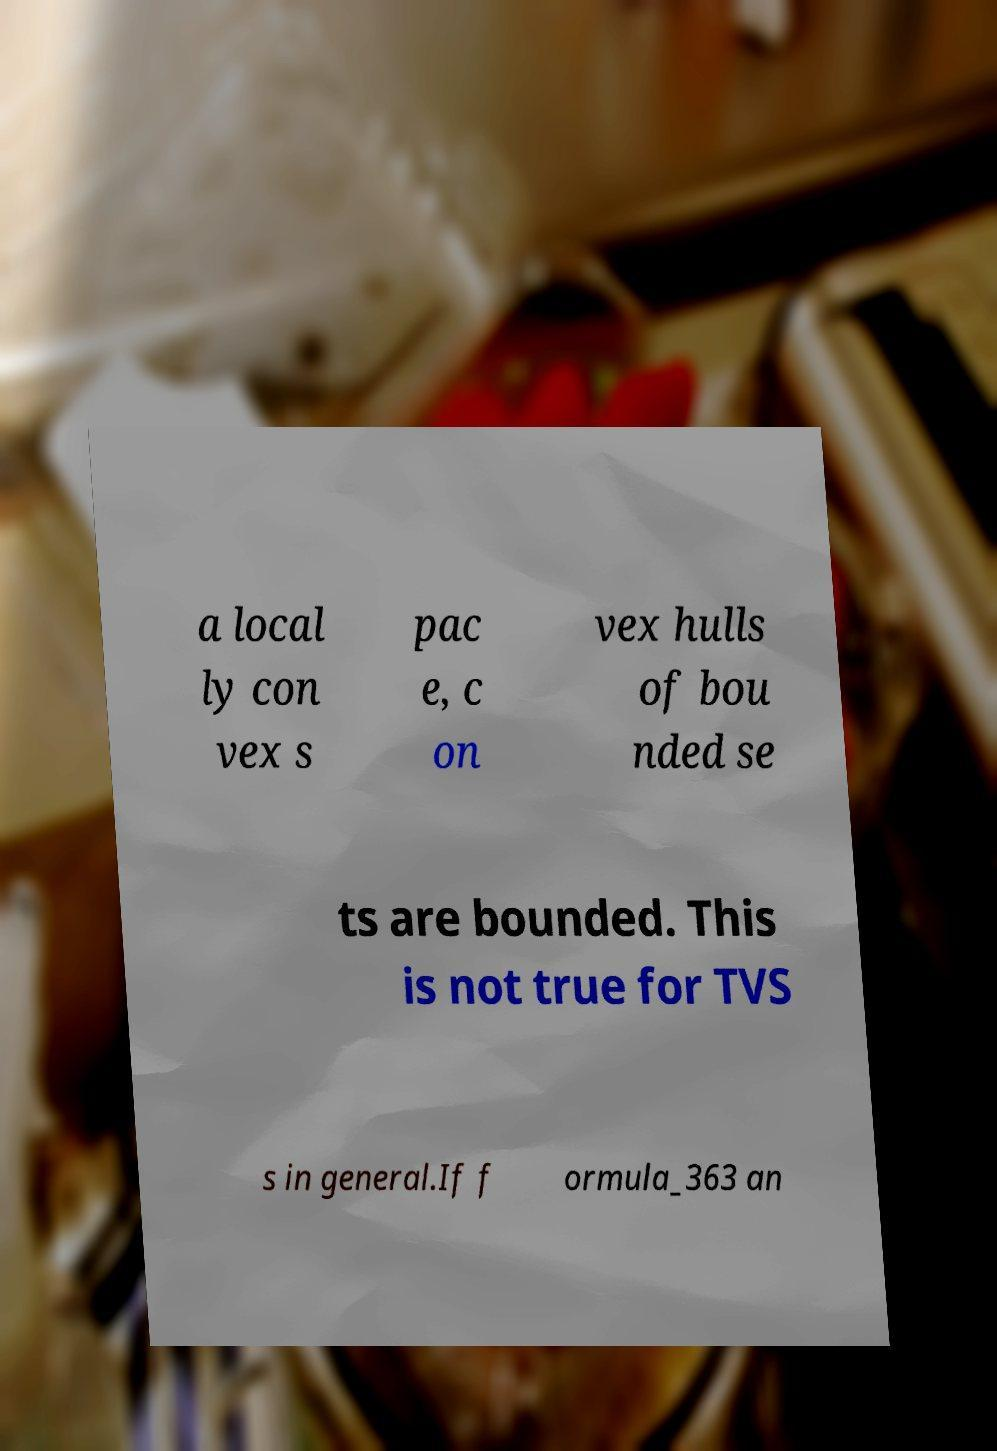There's text embedded in this image that I need extracted. Can you transcribe it verbatim? a local ly con vex s pac e, c on vex hulls of bou nded se ts are bounded. This is not true for TVS s in general.If f ormula_363 an 